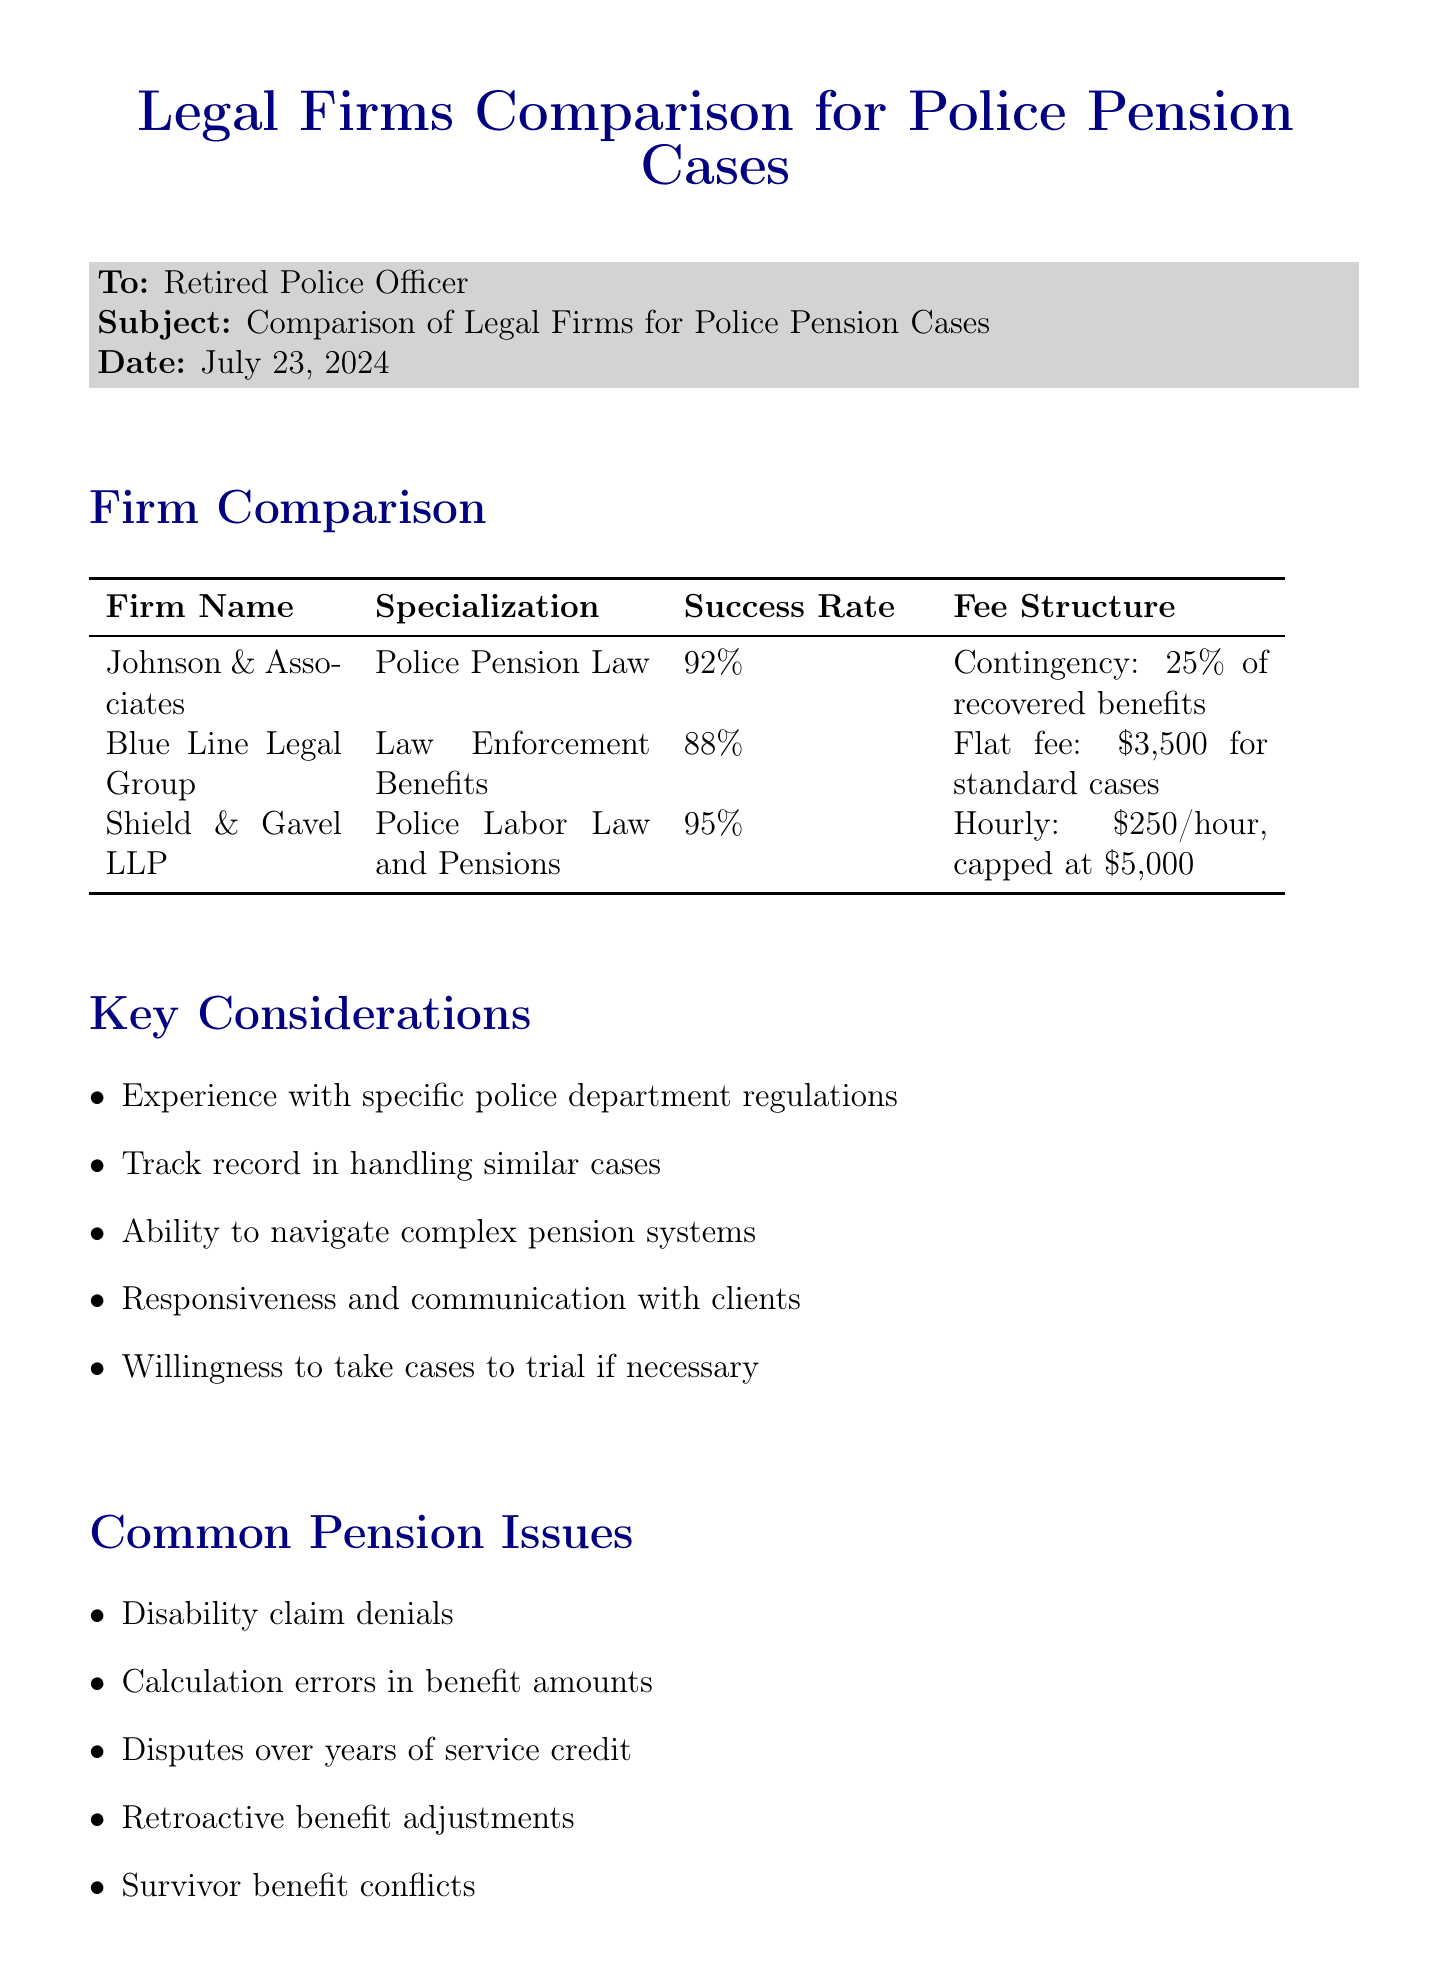What is the success rate of Shield & Gavel LLP? The success rate of Shield & Gavel LLP is stated in the document as 95%.
Answer: 95% What is the fee structure for Johnson & Associates? The fee structure for Johnson & Associates is a contingency fee of 25% of recovered benefits.
Answer: Contingency fee: 25% of recovered benefits Which legal firm specializes in Law Enforcement Benefits? The document specifically identifies Blue Line Legal Group as specializing in Law Enforcement Benefits.
Answer: Blue Line Legal Group What notable case is associated with Blue Line Legal Group? The document mentions that Blue Line Legal Group successfully appealed a denied pension claim for a Chicago PD sergeant.
Answer: Successfully appealed denied pension claim for Chicago PD sergeant What is a common pension issue mentioned in the document? The document lists several common pension issues; one of them is disability claim denials.
Answer: Disability claim denials How many officers did Shield & Gavel LLP secure retroactive benefits for? The document indicates that Shield & Gavel LLP secured retroactive benefits for 50 LAPD officers in a class action suit.
Answer: 50 What is one key consideration when choosing a legal firm? The document lists several key considerations, including experience with specific police department regulations.
Answer: Experience with specific police department regulations Name one additional resource mentioned in the document. The document refers to the National Association of Police Organizations (NAPO) as an additional resource.
Answer: National Association of Police Organizations (NAPO) 